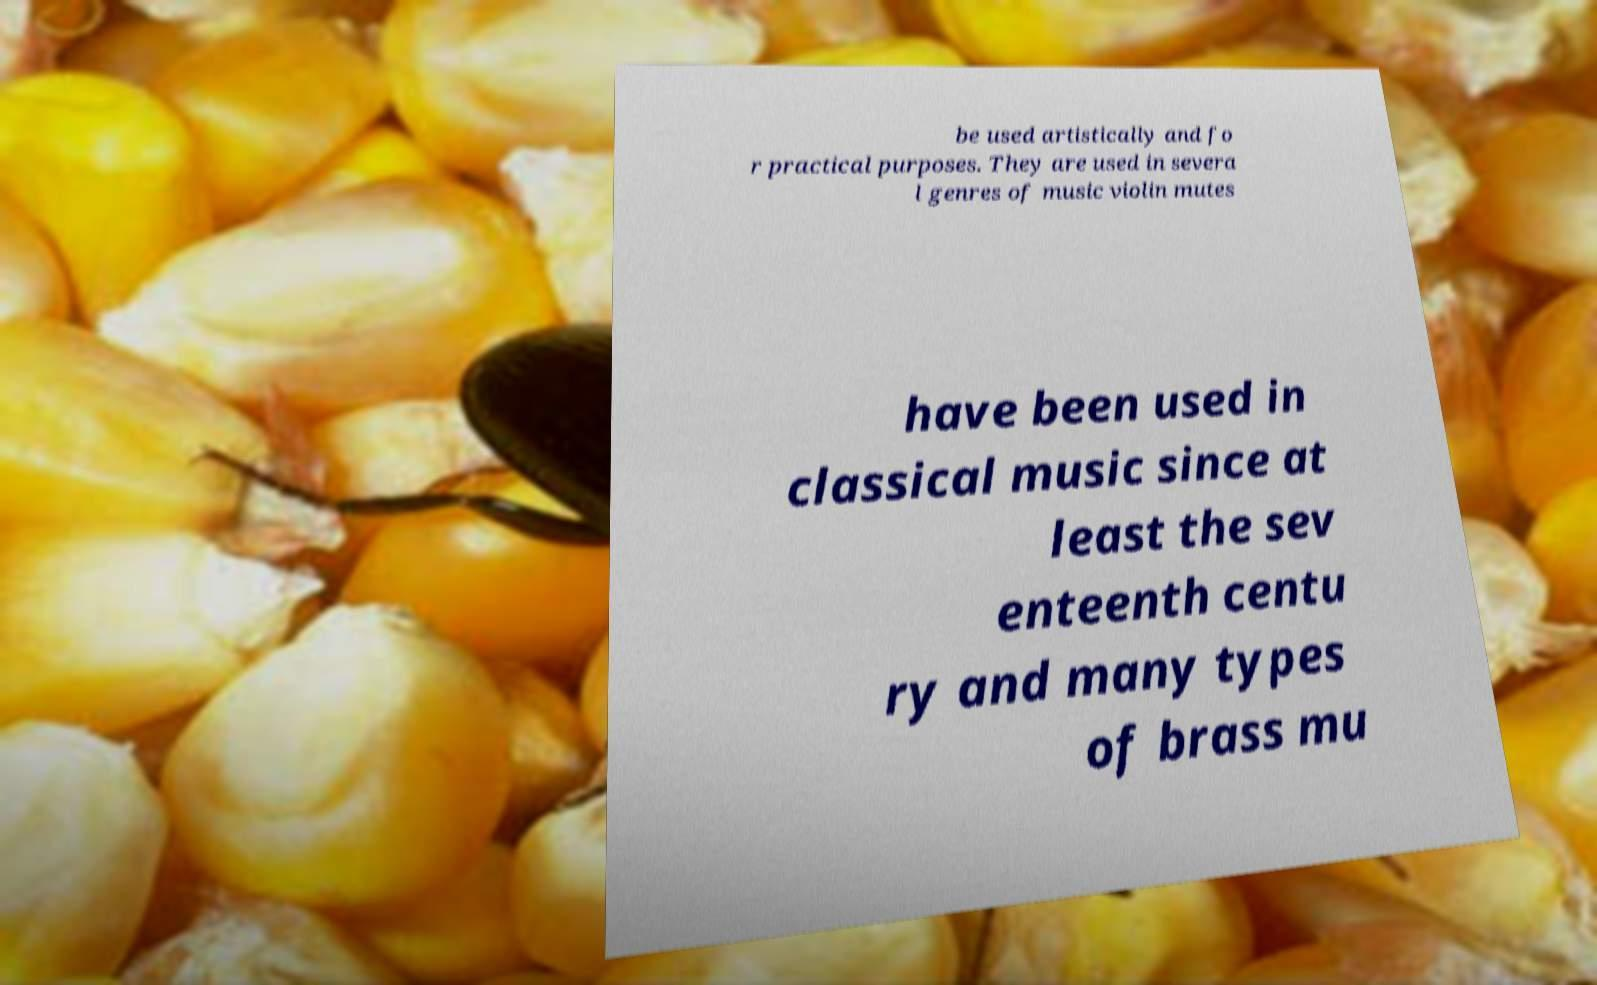Please identify and transcribe the text found in this image. be used artistically and fo r practical purposes. They are used in severa l genres of music violin mutes have been used in classical music since at least the sev enteenth centu ry and many types of brass mu 